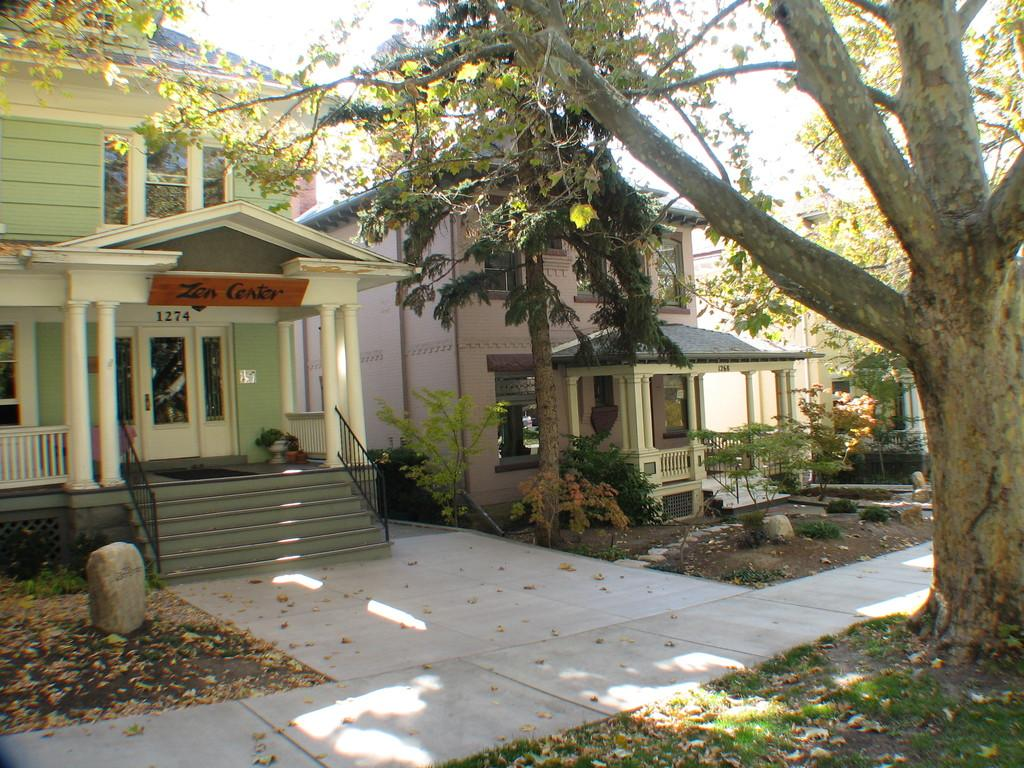What type of structures are visible in the image? There are buildings in the image. What features can be seen on the buildings? The buildings have windows, doors, pillars, and steps with railings. What type of vegetation is present in the image? There are plants, leaves on the ground, grass, and trees in the image. How many wristwatches can be seen on the buildings in the image? There are no wristwatches visible on the buildings in the image. Is there a mailbox present in the image? There is no mention of a mailbox in the provided facts, so it cannot be determined if one is present in the image. 